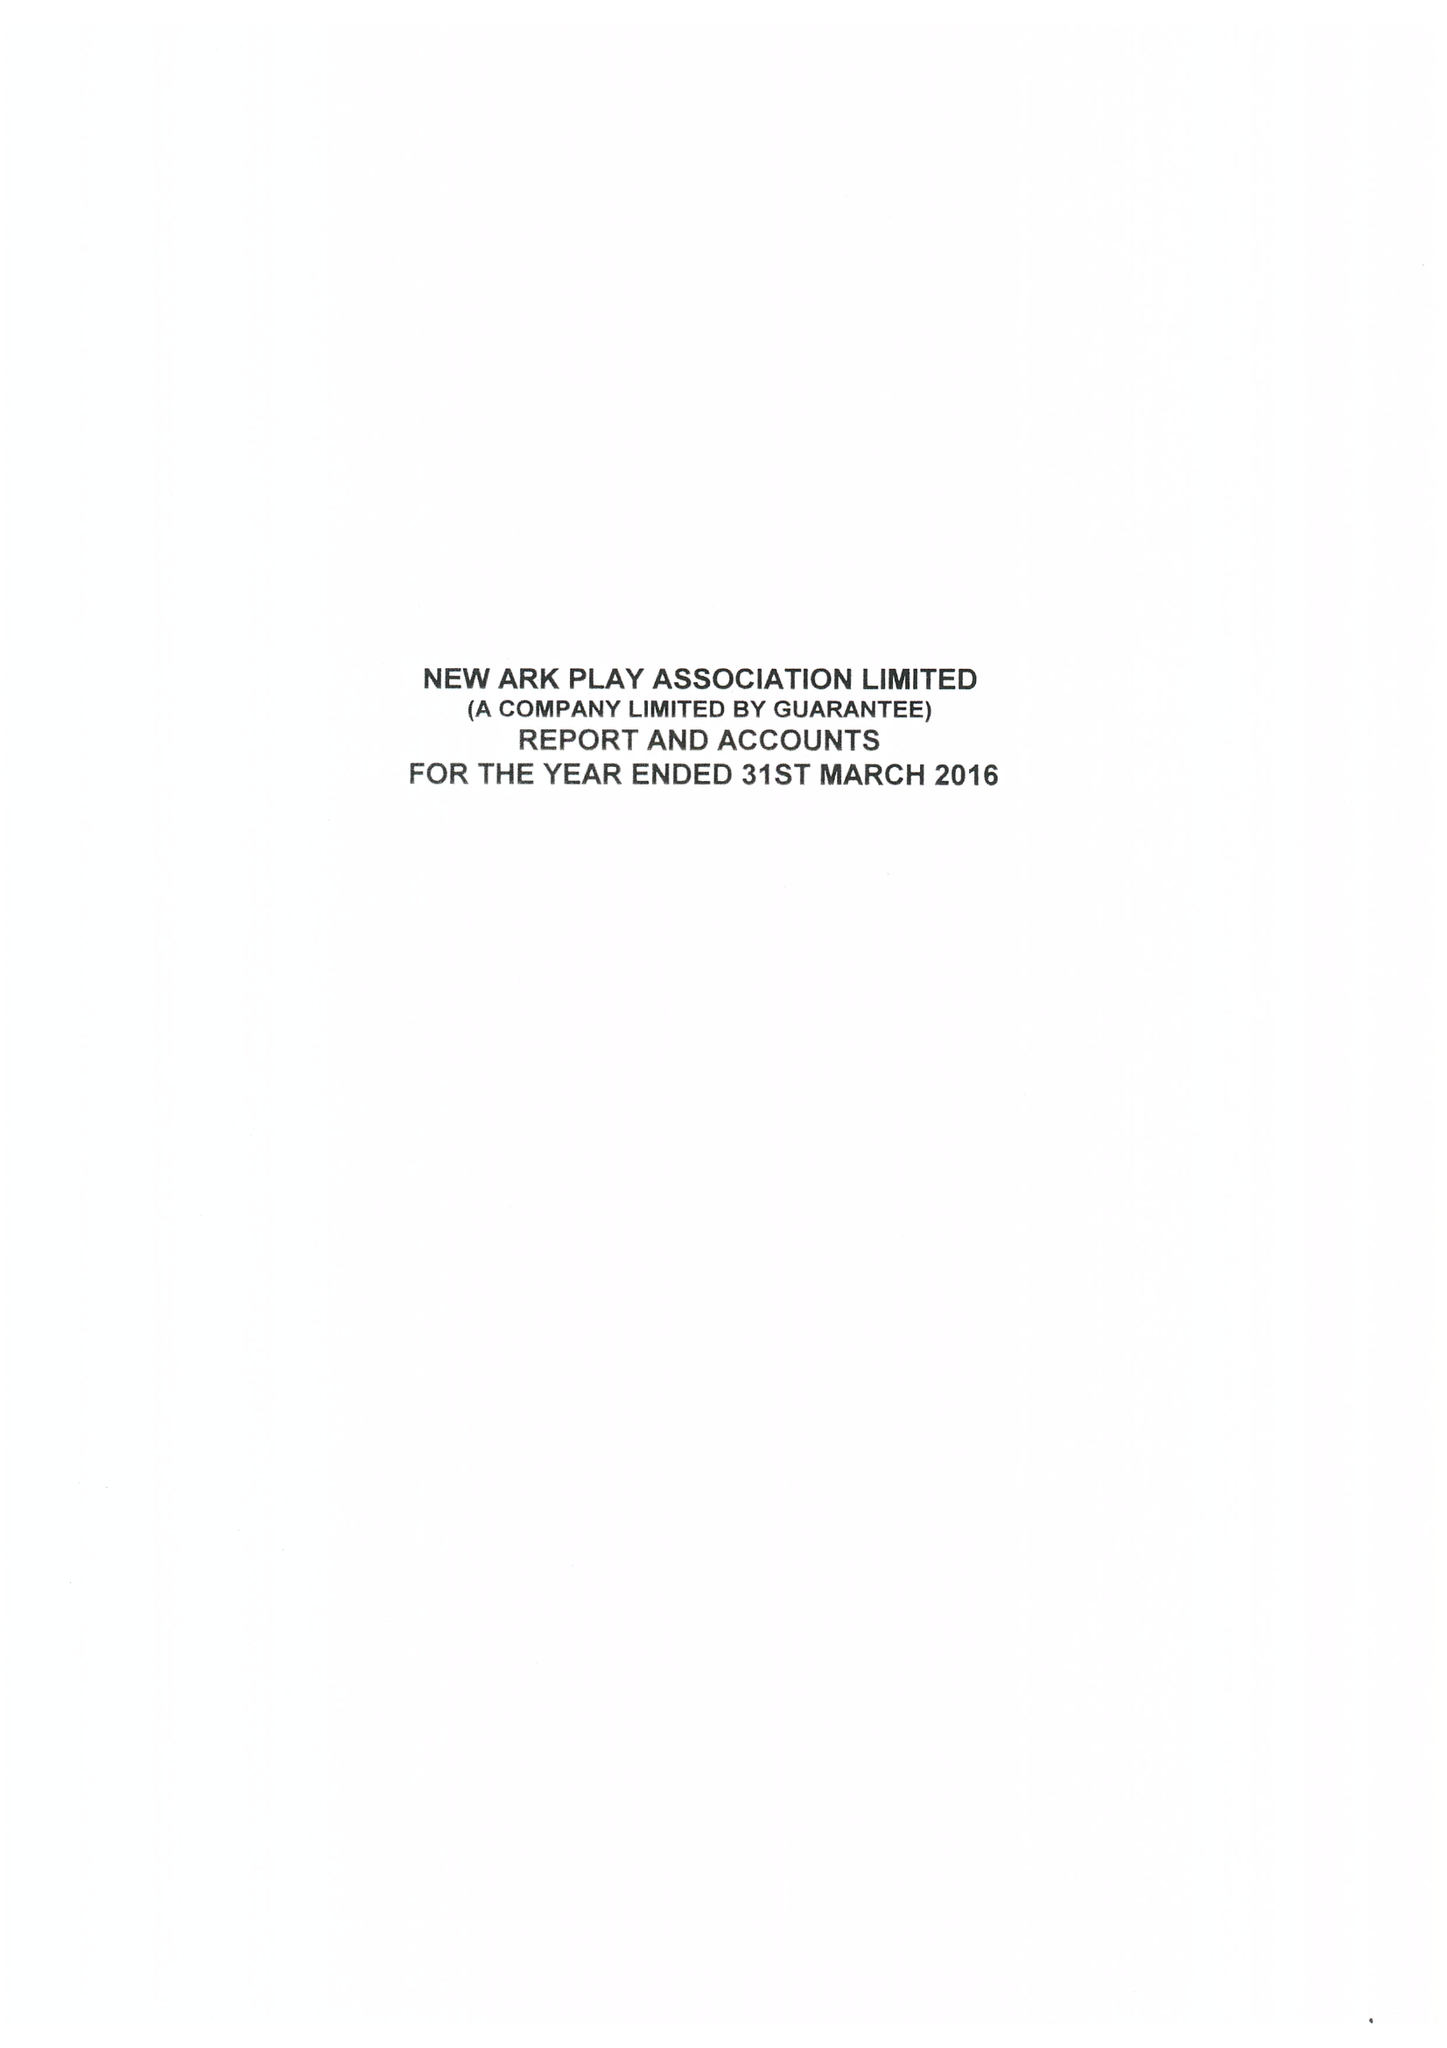What is the value for the charity_number?
Answer the question using a single word or phrase. 1026751 